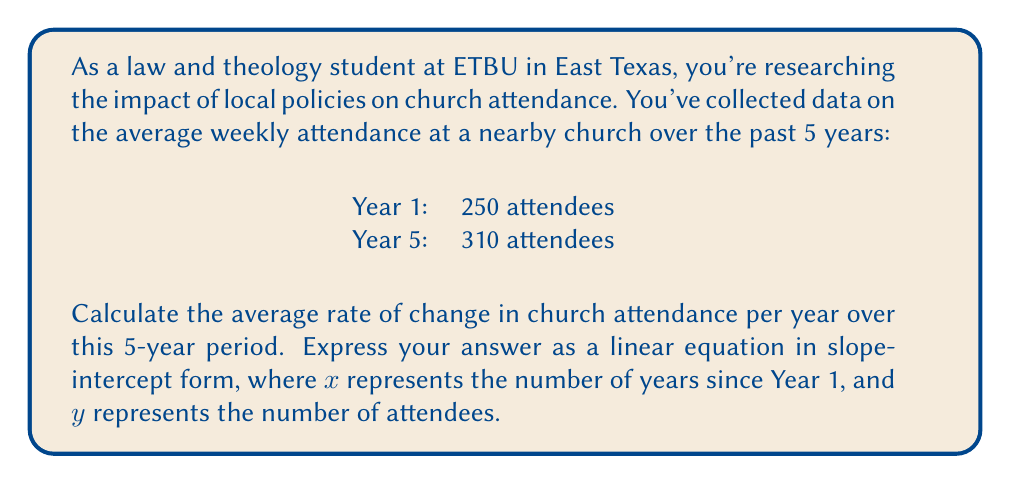Give your solution to this math problem. To solve this problem, we'll follow these steps:

1) First, let's calculate the total change in attendance:
   $\text{Change in attendance} = 310 - 250 = 60$ attendees

2) Now, we'll calculate the rate of change (slope) per year:
   $\text{Rate of change} = \frac{\text{Change in attendance}}{\text{Number of years}}$
   $= \frac{60}{5-1} = \frac{60}{4} = 15$ attendees per year

3) This rate of change represents the slope (m) in our linear equation.

4) To find the y-intercept (b), we can use the initial attendance (Year 1):
   $y = mx + b$
   $250 = 15(0) + b$
   $b = 250$

5) Now we can write our equation in slope-intercept form:
   $y = 15x + 250$

Where:
- $y$ represents the number of attendees
- $x$ represents the number of years since Year 1
- 15 is the rate of change (slope) in attendees per year
- 250 is the initial attendance (y-intercept)
Answer: $y = 15x + 250$ 